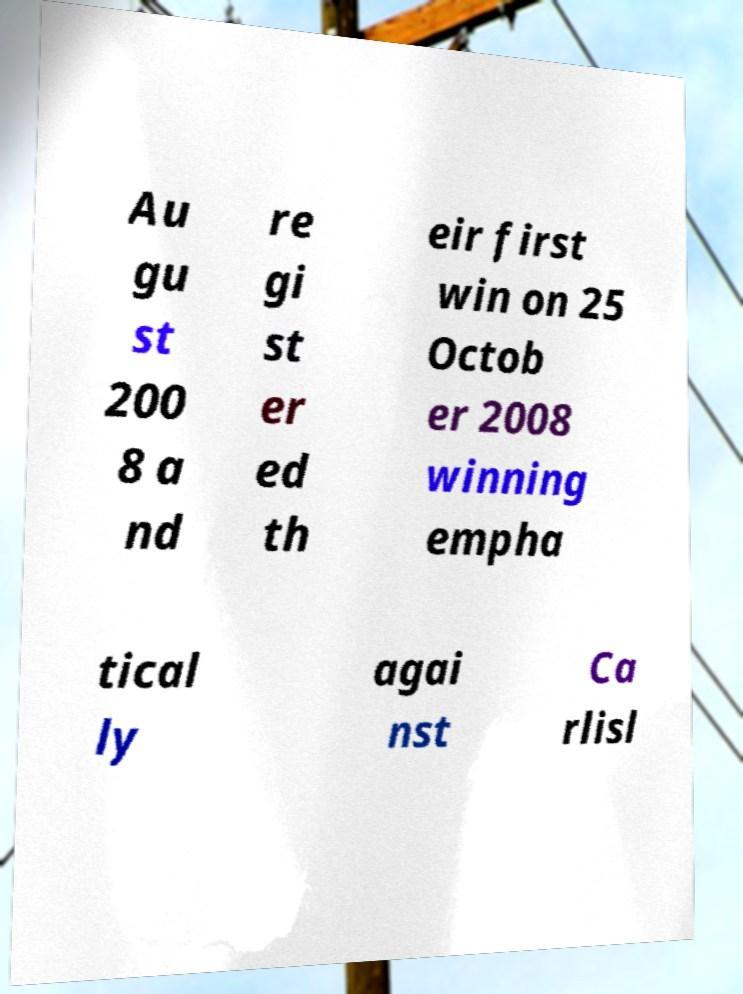Could you extract and type out the text from this image? Au gu st 200 8 a nd re gi st er ed th eir first win on 25 Octob er 2008 winning empha tical ly agai nst Ca rlisl 